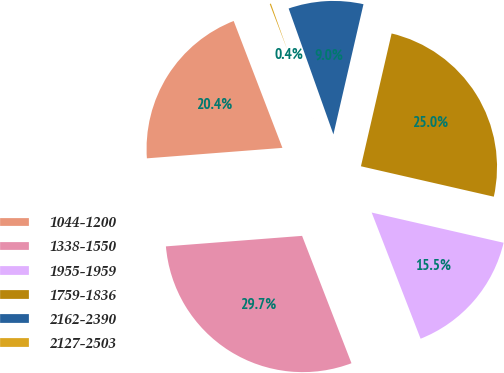<chart> <loc_0><loc_0><loc_500><loc_500><pie_chart><fcel>1044-1200<fcel>1338-1550<fcel>1955-1959<fcel>1759-1836<fcel>2162-2390<fcel>2127-2503<nl><fcel>20.39%<fcel>29.66%<fcel>15.53%<fcel>24.97%<fcel>9.05%<fcel>0.4%<nl></chart> 